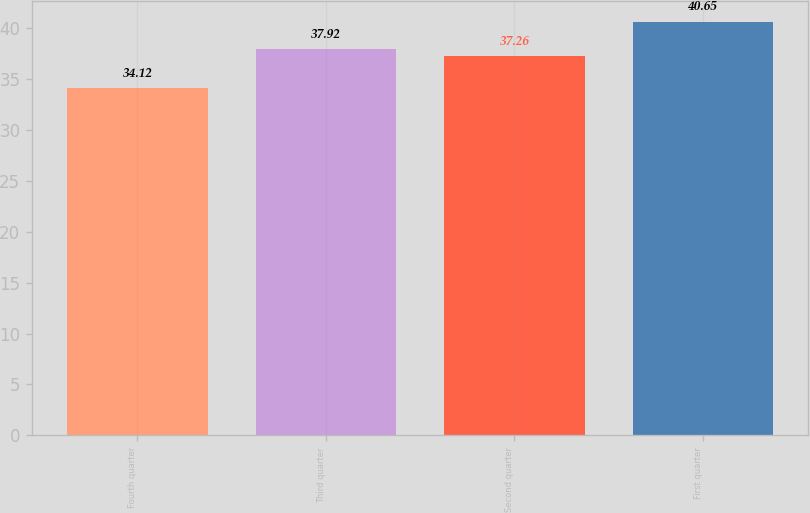Convert chart. <chart><loc_0><loc_0><loc_500><loc_500><bar_chart><fcel>Fourth quarter<fcel>Third quarter<fcel>Second quarter<fcel>First quarter<nl><fcel>34.12<fcel>37.92<fcel>37.26<fcel>40.65<nl></chart> 